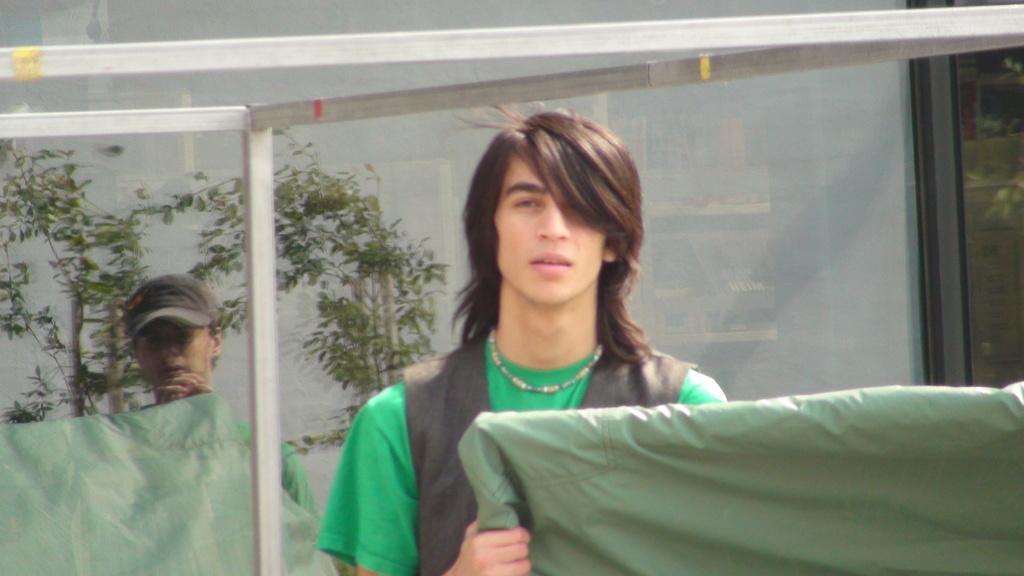Could you give a brief overview of what you see in this image? In this picture we can observe a man standing wearing green color T shirt. On the left side there is another person wearing cap on their head. We can observe plants. In the background there is a wall which is in white color. 